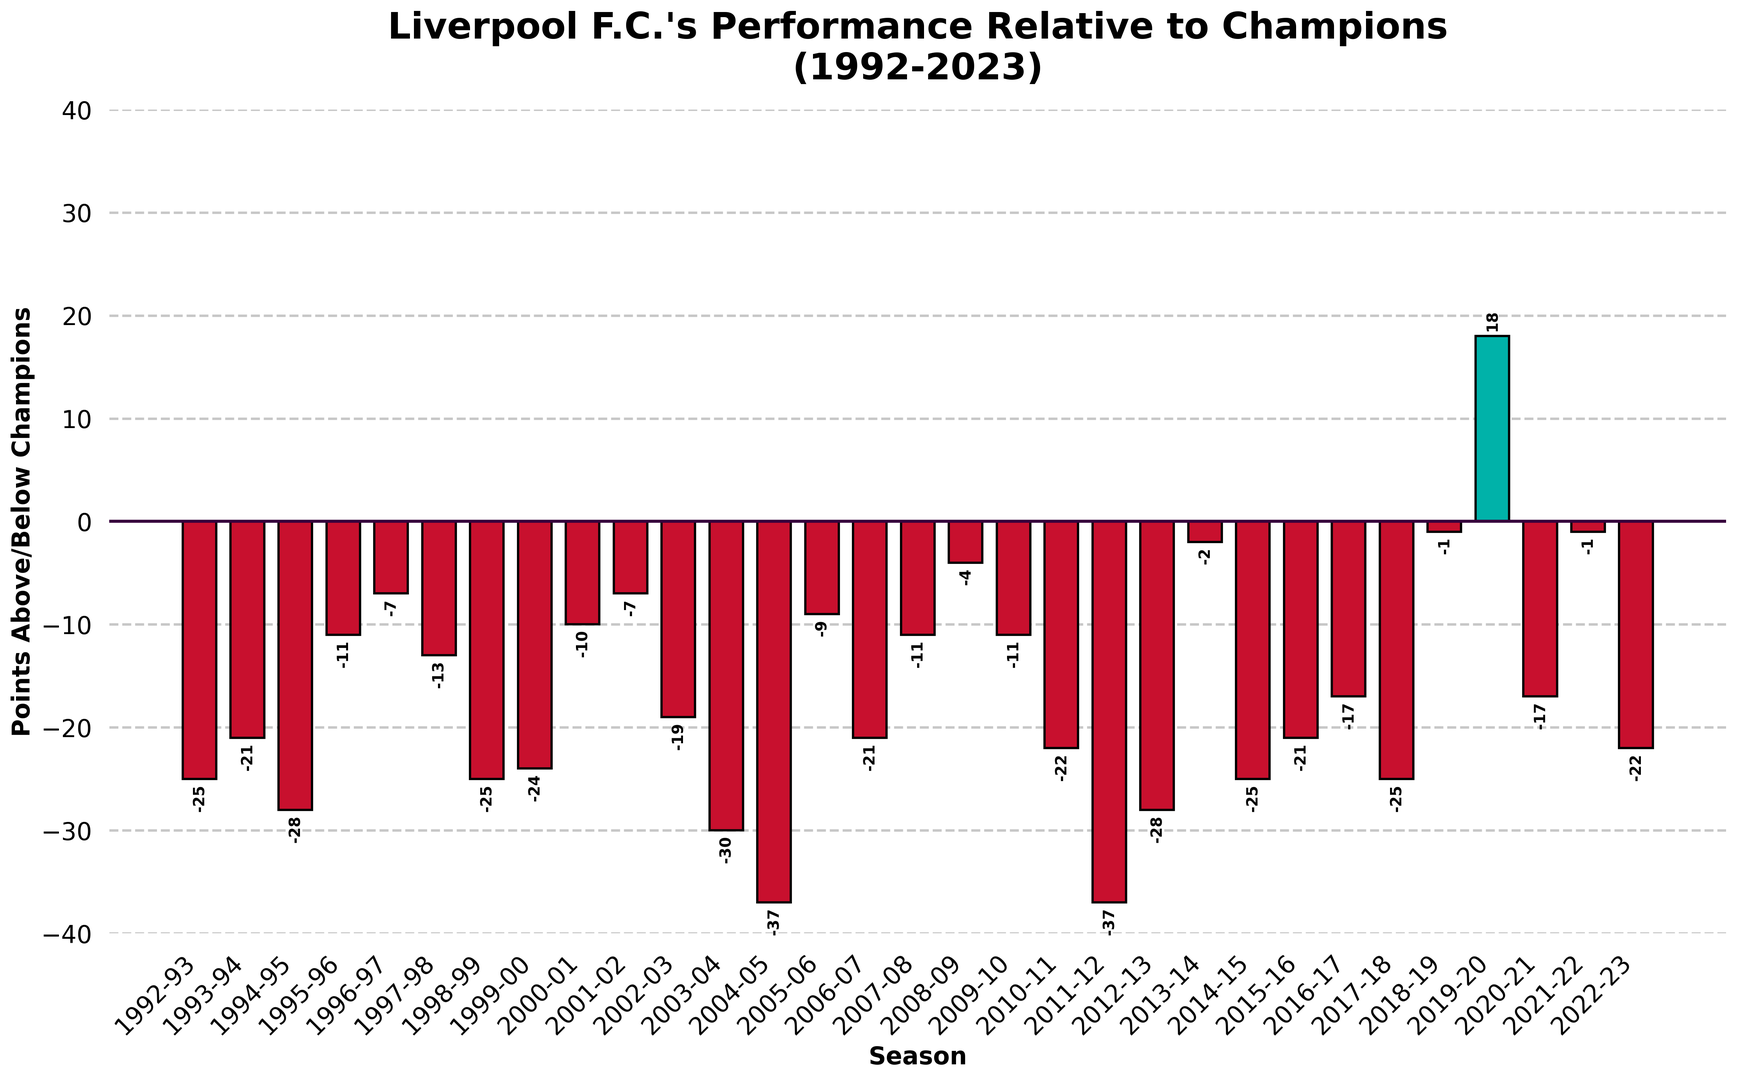Which seasons had a points difference of exactly -25? Look for bars that align with the -25 mark on the y-axis. The seasons represented by those bars are the ones you need.
Answer: 1992-93, 1998-99, 2014-15, 2017-18 What was Liverpool's highest positive points difference compared to the champions? Identify the tallest green bar on the positive side of the y-axis. The height of this bar indicates the highest positive points difference.
Answer: 18 How many seasons had Liverpool's points difference below -30? Count the bars that extend to -30 or below on the y-axis. These bars represent the seasons where the points difference was below -30.
Answer: 2 Which season had the smallest negative points difference? Look for the shortest red bar on the negative side of the y-axis. This bar represents the season with the smallest negative points difference.
Answer: 2008-09 What is the average points difference between 2000-01 and 2005-06 inclusive? Sum the points differences for the seasons from 2000-01 to 2005-06 inclusive, then divide by the number of seasons. The differences are: -10, -7, -19, -30, -37, -9. The sum is -112, and there are 6 seasons, so the average is -112/6.
Answer: -18.67 Which seasons are represented by green bars? Green bars represent seasons where Liverpool's points difference was positive. Identify these bars’ seasons by their position on the x-axis.
Answer: 2019-20 In which season did Liverpool have the worst performance compared to the champions? Find the tallest red bar on the negative side of the y-axis. This bar represents the season with the greatest negative difference.
Answer: 2011-12 Which two consecutive seasons had the smallest change in points difference? Calculate the differences in points difference between consecutive seasons, and find the pair with the smallest change. The smallest change is from 2020-21 (-17) to 2021-22 (-1). The change is 16 points.
Answer: 2020-21 to 2021-22 What was the points difference in the 2003-04 season? Locate the bar representing the 2003-04 season and read its height on the y-axis.
Answer: -30 Between which two seasons did Liverpool's points difference improve the most? Find the largest positive change in points difference by comparing consecutive bars. The biggest improvement is from 2011-12 (-37) to 2012-13 (-28). The improvement is 9 points.
Answer: 2011-12 to 2012-13 